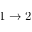<formula> <loc_0><loc_0><loc_500><loc_500>1 \to 2</formula> 